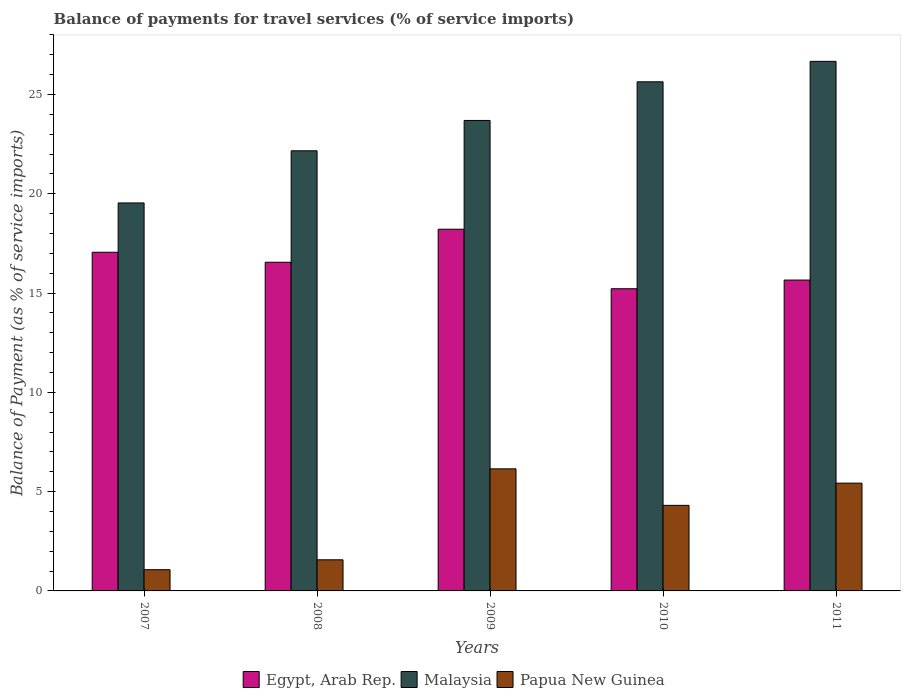How many groups of bars are there?
Offer a very short reply. 5. Are the number of bars on each tick of the X-axis equal?
Your answer should be compact. Yes. In how many cases, is the number of bars for a given year not equal to the number of legend labels?
Your response must be concise. 0. What is the balance of payments for travel services in Papua New Guinea in 2007?
Offer a terse response. 1.07. Across all years, what is the maximum balance of payments for travel services in Malaysia?
Keep it short and to the point. 26.67. Across all years, what is the minimum balance of payments for travel services in Papua New Guinea?
Offer a very short reply. 1.07. What is the total balance of payments for travel services in Egypt, Arab Rep. in the graph?
Ensure brevity in your answer.  82.69. What is the difference between the balance of payments for travel services in Egypt, Arab Rep. in 2007 and that in 2010?
Make the answer very short. 1.84. What is the difference between the balance of payments for travel services in Malaysia in 2010 and the balance of payments for travel services in Egypt, Arab Rep. in 2009?
Offer a very short reply. 7.42. What is the average balance of payments for travel services in Egypt, Arab Rep. per year?
Provide a short and direct response. 16.54. In the year 2011, what is the difference between the balance of payments for travel services in Malaysia and balance of payments for travel services in Egypt, Arab Rep.?
Your response must be concise. 11.01. In how many years, is the balance of payments for travel services in Papua New Guinea greater than 4 %?
Offer a terse response. 3. What is the ratio of the balance of payments for travel services in Papua New Guinea in 2008 to that in 2010?
Keep it short and to the point. 0.36. What is the difference between the highest and the second highest balance of payments for travel services in Malaysia?
Your response must be concise. 1.03. What is the difference between the highest and the lowest balance of payments for travel services in Papua New Guinea?
Give a very brief answer. 5.08. In how many years, is the balance of payments for travel services in Egypt, Arab Rep. greater than the average balance of payments for travel services in Egypt, Arab Rep. taken over all years?
Provide a short and direct response. 3. What does the 3rd bar from the left in 2011 represents?
Your answer should be compact. Papua New Guinea. What does the 3rd bar from the right in 2007 represents?
Ensure brevity in your answer.  Egypt, Arab Rep. Are all the bars in the graph horizontal?
Your answer should be very brief. No. How many years are there in the graph?
Provide a short and direct response. 5. Are the values on the major ticks of Y-axis written in scientific E-notation?
Provide a succinct answer. No. Where does the legend appear in the graph?
Give a very brief answer. Bottom center. How many legend labels are there?
Offer a very short reply. 3. How are the legend labels stacked?
Offer a very short reply. Horizontal. What is the title of the graph?
Your answer should be very brief. Balance of payments for travel services (% of service imports). Does "Brazil" appear as one of the legend labels in the graph?
Provide a succinct answer. No. What is the label or title of the Y-axis?
Give a very brief answer. Balance of Payment (as % of service imports). What is the Balance of Payment (as % of service imports) of Egypt, Arab Rep. in 2007?
Offer a terse response. 17.05. What is the Balance of Payment (as % of service imports) in Malaysia in 2007?
Provide a succinct answer. 19.54. What is the Balance of Payment (as % of service imports) of Papua New Guinea in 2007?
Provide a succinct answer. 1.07. What is the Balance of Payment (as % of service imports) in Egypt, Arab Rep. in 2008?
Keep it short and to the point. 16.55. What is the Balance of Payment (as % of service imports) of Malaysia in 2008?
Give a very brief answer. 22.16. What is the Balance of Payment (as % of service imports) in Papua New Guinea in 2008?
Keep it short and to the point. 1.57. What is the Balance of Payment (as % of service imports) in Egypt, Arab Rep. in 2009?
Keep it short and to the point. 18.21. What is the Balance of Payment (as % of service imports) in Malaysia in 2009?
Provide a short and direct response. 23.69. What is the Balance of Payment (as % of service imports) of Papua New Guinea in 2009?
Provide a succinct answer. 6.15. What is the Balance of Payment (as % of service imports) of Egypt, Arab Rep. in 2010?
Your response must be concise. 15.22. What is the Balance of Payment (as % of service imports) in Malaysia in 2010?
Provide a short and direct response. 25.64. What is the Balance of Payment (as % of service imports) in Papua New Guinea in 2010?
Your answer should be compact. 4.31. What is the Balance of Payment (as % of service imports) in Egypt, Arab Rep. in 2011?
Give a very brief answer. 15.65. What is the Balance of Payment (as % of service imports) of Malaysia in 2011?
Offer a terse response. 26.67. What is the Balance of Payment (as % of service imports) in Papua New Guinea in 2011?
Provide a short and direct response. 5.43. Across all years, what is the maximum Balance of Payment (as % of service imports) in Egypt, Arab Rep.?
Your answer should be compact. 18.21. Across all years, what is the maximum Balance of Payment (as % of service imports) of Malaysia?
Make the answer very short. 26.67. Across all years, what is the maximum Balance of Payment (as % of service imports) in Papua New Guinea?
Give a very brief answer. 6.15. Across all years, what is the minimum Balance of Payment (as % of service imports) of Egypt, Arab Rep.?
Your response must be concise. 15.22. Across all years, what is the minimum Balance of Payment (as % of service imports) in Malaysia?
Provide a short and direct response. 19.54. Across all years, what is the minimum Balance of Payment (as % of service imports) in Papua New Guinea?
Give a very brief answer. 1.07. What is the total Balance of Payment (as % of service imports) in Egypt, Arab Rep. in the graph?
Offer a very short reply. 82.69. What is the total Balance of Payment (as % of service imports) in Malaysia in the graph?
Offer a very short reply. 117.7. What is the total Balance of Payment (as % of service imports) of Papua New Guinea in the graph?
Keep it short and to the point. 18.52. What is the difference between the Balance of Payment (as % of service imports) in Egypt, Arab Rep. in 2007 and that in 2008?
Offer a very short reply. 0.5. What is the difference between the Balance of Payment (as % of service imports) in Malaysia in 2007 and that in 2008?
Provide a short and direct response. -2.63. What is the difference between the Balance of Payment (as % of service imports) in Papua New Guinea in 2007 and that in 2008?
Provide a short and direct response. -0.5. What is the difference between the Balance of Payment (as % of service imports) of Egypt, Arab Rep. in 2007 and that in 2009?
Provide a succinct answer. -1.16. What is the difference between the Balance of Payment (as % of service imports) in Malaysia in 2007 and that in 2009?
Your response must be concise. -4.15. What is the difference between the Balance of Payment (as % of service imports) in Papua New Guinea in 2007 and that in 2009?
Give a very brief answer. -5.08. What is the difference between the Balance of Payment (as % of service imports) of Egypt, Arab Rep. in 2007 and that in 2010?
Ensure brevity in your answer.  1.84. What is the difference between the Balance of Payment (as % of service imports) of Malaysia in 2007 and that in 2010?
Offer a very short reply. -6.1. What is the difference between the Balance of Payment (as % of service imports) of Papua New Guinea in 2007 and that in 2010?
Your response must be concise. -3.24. What is the difference between the Balance of Payment (as % of service imports) of Egypt, Arab Rep. in 2007 and that in 2011?
Offer a terse response. 1.4. What is the difference between the Balance of Payment (as % of service imports) in Malaysia in 2007 and that in 2011?
Offer a terse response. -7.13. What is the difference between the Balance of Payment (as % of service imports) of Papua New Guinea in 2007 and that in 2011?
Give a very brief answer. -4.36. What is the difference between the Balance of Payment (as % of service imports) in Egypt, Arab Rep. in 2008 and that in 2009?
Keep it short and to the point. -1.66. What is the difference between the Balance of Payment (as % of service imports) of Malaysia in 2008 and that in 2009?
Provide a succinct answer. -1.53. What is the difference between the Balance of Payment (as % of service imports) of Papua New Guinea in 2008 and that in 2009?
Offer a very short reply. -4.58. What is the difference between the Balance of Payment (as % of service imports) of Egypt, Arab Rep. in 2008 and that in 2010?
Offer a very short reply. 1.33. What is the difference between the Balance of Payment (as % of service imports) in Malaysia in 2008 and that in 2010?
Provide a succinct answer. -3.47. What is the difference between the Balance of Payment (as % of service imports) of Papua New Guinea in 2008 and that in 2010?
Your answer should be very brief. -2.74. What is the difference between the Balance of Payment (as % of service imports) of Egypt, Arab Rep. in 2008 and that in 2011?
Ensure brevity in your answer.  0.9. What is the difference between the Balance of Payment (as % of service imports) of Malaysia in 2008 and that in 2011?
Provide a succinct answer. -4.5. What is the difference between the Balance of Payment (as % of service imports) in Papua New Guinea in 2008 and that in 2011?
Provide a short and direct response. -3.86. What is the difference between the Balance of Payment (as % of service imports) in Egypt, Arab Rep. in 2009 and that in 2010?
Provide a short and direct response. 3. What is the difference between the Balance of Payment (as % of service imports) in Malaysia in 2009 and that in 2010?
Make the answer very short. -1.95. What is the difference between the Balance of Payment (as % of service imports) in Papua New Guinea in 2009 and that in 2010?
Your response must be concise. 1.84. What is the difference between the Balance of Payment (as % of service imports) of Egypt, Arab Rep. in 2009 and that in 2011?
Your response must be concise. 2.56. What is the difference between the Balance of Payment (as % of service imports) of Malaysia in 2009 and that in 2011?
Provide a short and direct response. -2.98. What is the difference between the Balance of Payment (as % of service imports) in Papua New Guinea in 2009 and that in 2011?
Make the answer very short. 0.72. What is the difference between the Balance of Payment (as % of service imports) of Egypt, Arab Rep. in 2010 and that in 2011?
Make the answer very short. -0.44. What is the difference between the Balance of Payment (as % of service imports) of Malaysia in 2010 and that in 2011?
Provide a short and direct response. -1.03. What is the difference between the Balance of Payment (as % of service imports) in Papua New Guinea in 2010 and that in 2011?
Give a very brief answer. -1.12. What is the difference between the Balance of Payment (as % of service imports) of Egypt, Arab Rep. in 2007 and the Balance of Payment (as % of service imports) of Malaysia in 2008?
Provide a succinct answer. -5.11. What is the difference between the Balance of Payment (as % of service imports) of Egypt, Arab Rep. in 2007 and the Balance of Payment (as % of service imports) of Papua New Guinea in 2008?
Your answer should be very brief. 15.49. What is the difference between the Balance of Payment (as % of service imports) of Malaysia in 2007 and the Balance of Payment (as % of service imports) of Papua New Guinea in 2008?
Your answer should be very brief. 17.97. What is the difference between the Balance of Payment (as % of service imports) of Egypt, Arab Rep. in 2007 and the Balance of Payment (as % of service imports) of Malaysia in 2009?
Your answer should be very brief. -6.64. What is the difference between the Balance of Payment (as % of service imports) of Egypt, Arab Rep. in 2007 and the Balance of Payment (as % of service imports) of Papua New Guinea in 2009?
Your answer should be compact. 10.91. What is the difference between the Balance of Payment (as % of service imports) in Malaysia in 2007 and the Balance of Payment (as % of service imports) in Papua New Guinea in 2009?
Your answer should be compact. 13.39. What is the difference between the Balance of Payment (as % of service imports) in Egypt, Arab Rep. in 2007 and the Balance of Payment (as % of service imports) in Malaysia in 2010?
Keep it short and to the point. -8.58. What is the difference between the Balance of Payment (as % of service imports) in Egypt, Arab Rep. in 2007 and the Balance of Payment (as % of service imports) in Papua New Guinea in 2010?
Your answer should be very brief. 12.74. What is the difference between the Balance of Payment (as % of service imports) in Malaysia in 2007 and the Balance of Payment (as % of service imports) in Papua New Guinea in 2010?
Give a very brief answer. 15.23. What is the difference between the Balance of Payment (as % of service imports) in Egypt, Arab Rep. in 2007 and the Balance of Payment (as % of service imports) in Malaysia in 2011?
Offer a terse response. -9.61. What is the difference between the Balance of Payment (as % of service imports) in Egypt, Arab Rep. in 2007 and the Balance of Payment (as % of service imports) in Papua New Guinea in 2011?
Give a very brief answer. 11.63. What is the difference between the Balance of Payment (as % of service imports) of Malaysia in 2007 and the Balance of Payment (as % of service imports) of Papua New Guinea in 2011?
Keep it short and to the point. 14.11. What is the difference between the Balance of Payment (as % of service imports) of Egypt, Arab Rep. in 2008 and the Balance of Payment (as % of service imports) of Malaysia in 2009?
Your answer should be compact. -7.14. What is the difference between the Balance of Payment (as % of service imports) in Egypt, Arab Rep. in 2008 and the Balance of Payment (as % of service imports) in Papua New Guinea in 2009?
Your response must be concise. 10.4. What is the difference between the Balance of Payment (as % of service imports) in Malaysia in 2008 and the Balance of Payment (as % of service imports) in Papua New Guinea in 2009?
Your response must be concise. 16.02. What is the difference between the Balance of Payment (as % of service imports) in Egypt, Arab Rep. in 2008 and the Balance of Payment (as % of service imports) in Malaysia in 2010?
Provide a succinct answer. -9.09. What is the difference between the Balance of Payment (as % of service imports) in Egypt, Arab Rep. in 2008 and the Balance of Payment (as % of service imports) in Papua New Guinea in 2010?
Give a very brief answer. 12.24. What is the difference between the Balance of Payment (as % of service imports) in Malaysia in 2008 and the Balance of Payment (as % of service imports) in Papua New Guinea in 2010?
Make the answer very short. 17.85. What is the difference between the Balance of Payment (as % of service imports) of Egypt, Arab Rep. in 2008 and the Balance of Payment (as % of service imports) of Malaysia in 2011?
Provide a short and direct response. -10.12. What is the difference between the Balance of Payment (as % of service imports) in Egypt, Arab Rep. in 2008 and the Balance of Payment (as % of service imports) in Papua New Guinea in 2011?
Your response must be concise. 11.12. What is the difference between the Balance of Payment (as % of service imports) of Malaysia in 2008 and the Balance of Payment (as % of service imports) of Papua New Guinea in 2011?
Your response must be concise. 16.74. What is the difference between the Balance of Payment (as % of service imports) in Egypt, Arab Rep. in 2009 and the Balance of Payment (as % of service imports) in Malaysia in 2010?
Make the answer very short. -7.42. What is the difference between the Balance of Payment (as % of service imports) in Egypt, Arab Rep. in 2009 and the Balance of Payment (as % of service imports) in Papua New Guinea in 2010?
Your answer should be compact. 13.9. What is the difference between the Balance of Payment (as % of service imports) in Malaysia in 2009 and the Balance of Payment (as % of service imports) in Papua New Guinea in 2010?
Provide a short and direct response. 19.38. What is the difference between the Balance of Payment (as % of service imports) in Egypt, Arab Rep. in 2009 and the Balance of Payment (as % of service imports) in Malaysia in 2011?
Your response must be concise. -8.45. What is the difference between the Balance of Payment (as % of service imports) of Egypt, Arab Rep. in 2009 and the Balance of Payment (as % of service imports) of Papua New Guinea in 2011?
Offer a terse response. 12.79. What is the difference between the Balance of Payment (as % of service imports) of Malaysia in 2009 and the Balance of Payment (as % of service imports) of Papua New Guinea in 2011?
Your response must be concise. 18.26. What is the difference between the Balance of Payment (as % of service imports) of Egypt, Arab Rep. in 2010 and the Balance of Payment (as % of service imports) of Malaysia in 2011?
Provide a short and direct response. -11.45. What is the difference between the Balance of Payment (as % of service imports) of Egypt, Arab Rep. in 2010 and the Balance of Payment (as % of service imports) of Papua New Guinea in 2011?
Provide a succinct answer. 9.79. What is the difference between the Balance of Payment (as % of service imports) of Malaysia in 2010 and the Balance of Payment (as % of service imports) of Papua New Guinea in 2011?
Offer a terse response. 20.21. What is the average Balance of Payment (as % of service imports) in Egypt, Arab Rep. per year?
Provide a succinct answer. 16.54. What is the average Balance of Payment (as % of service imports) in Malaysia per year?
Make the answer very short. 23.54. What is the average Balance of Payment (as % of service imports) of Papua New Guinea per year?
Provide a succinct answer. 3.7. In the year 2007, what is the difference between the Balance of Payment (as % of service imports) in Egypt, Arab Rep. and Balance of Payment (as % of service imports) in Malaysia?
Your response must be concise. -2.48. In the year 2007, what is the difference between the Balance of Payment (as % of service imports) in Egypt, Arab Rep. and Balance of Payment (as % of service imports) in Papua New Guinea?
Ensure brevity in your answer.  15.98. In the year 2007, what is the difference between the Balance of Payment (as % of service imports) in Malaysia and Balance of Payment (as % of service imports) in Papua New Guinea?
Provide a short and direct response. 18.47. In the year 2008, what is the difference between the Balance of Payment (as % of service imports) in Egypt, Arab Rep. and Balance of Payment (as % of service imports) in Malaysia?
Offer a very short reply. -5.61. In the year 2008, what is the difference between the Balance of Payment (as % of service imports) of Egypt, Arab Rep. and Balance of Payment (as % of service imports) of Papua New Guinea?
Your answer should be very brief. 14.98. In the year 2008, what is the difference between the Balance of Payment (as % of service imports) in Malaysia and Balance of Payment (as % of service imports) in Papua New Guinea?
Make the answer very short. 20.6. In the year 2009, what is the difference between the Balance of Payment (as % of service imports) of Egypt, Arab Rep. and Balance of Payment (as % of service imports) of Malaysia?
Your response must be concise. -5.48. In the year 2009, what is the difference between the Balance of Payment (as % of service imports) in Egypt, Arab Rep. and Balance of Payment (as % of service imports) in Papua New Guinea?
Ensure brevity in your answer.  12.07. In the year 2009, what is the difference between the Balance of Payment (as % of service imports) of Malaysia and Balance of Payment (as % of service imports) of Papua New Guinea?
Provide a short and direct response. 17.54. In the year 2010, what is the difference between the Balance of Payment (as % of service imports) of Egypt, Arab Rep. and Balance of Payment (as % of service imports) of Malaysia?
Make the answer very short. -10.42. In the year 2010, what is the difference between the Balance of Payment (as % of service imports) in Egypt, Arab Rep. and Balance of Payment (as % of service imports) in Papua New Guinea?
Provide a short and direct response. 10.91. In the year 2010, what is the difference between the Balance of Payment (as % of service imports) in Malaysia and Balance of Payment (as % of service imports) in Papua New Guinea?
Keep it short and to the point. 21.33. In the year 2011, what is the difference between the Balance of Payment (as % of service imports) in Egypt, Arab Rep. and Balance of Payment (as % of service imports) in Malaysia?
Your response must be concise. -11.01. In the year 2011, what is the difference between the Balance of Payment (as % of service imports) in Egypt, Arab Rep. and Balance of Payment (as % of service imports) in Papua New Guinea?
Give a very brief answer. 10.23. In the year 2011, what is the difference between the Balance of Payment (as % of service imports) of Malaysia and Balance of Payment (as % of service imports) of Papua New Guinea?
Offer a terse response. 21.24. What is the ratio of the Balance of Payment (as % of service imports) of Egypt, Arab Rep. in 2007 to that in 2008?
Your response must be concise. 1.03. What is the ratio of the Balance of Payment (as % of service imports) of Malaysia in 2007 to that in 2008?
Give a very brief answer. 0.88. What is the ratio of the Balance of Payment (as % of service imports) of Papua New Guinea in 2007 to that in 2008?
Provide a succinct answer. 0.68. What is the ratio of the Balance of Payment (as % of service imports) of Egypt, Arab Rep. in 2007 to that in 2009?
Ensure brevity in your answer.  0.94. What is the ratio of the Balance of Payment (as % of service imports) of Malaysia in 2007 to that in 2009?
Your answer should be compact. 0.82. What is the ratio of the Balance of Payment (as % of service imports) of Papua New Guinea in 2007 to that in 2009?
Ensure brevity in your answer.  0.17. What is the ratio of the Balance of Payment (as % of service imports) in Egypt, Arab Rep. in 2007 to that in 2010?
Provide a succinct answer. 1.12. What is the ratio of the Balance of Payment (as % of service imports) of Malaysia in 2007 to that in 2010?
Make the answer very short. 0.76. What is the ratio of the Balance of Payment (as % of service imports) of Papua New Guinea in 2007 to that in 2010?
Your response must be concise. 0.25. What is the ratio of the Balance of Payment (as % of service imports) of Egypt, Arab Rep. in 2007 to that in 2011?
Offer a terse response. 1.09. What is the ratio of the Balance of Payment (as % of service imports) in Malaysia in 2007 to that in 2011?
Keep it short and to the point. 0.73. What is the ratio of the Balance of Payment (as % of service imports) of Papua New Guinea in 2007 to that in 2011?
Your response must be concise. 0.2. What is the ratio of the Balance of Payment (as % of service imports) of Egypt, Arab Rep. in 2008 to that in 2009?
Make the answer very short. 0.91. What is the ratio of the Balance of Payment (as % of service imports) in Malaysia in 2008 to that in 2009?
Provide a succinct answer. 0.94. What is the ratio of the Balance of Payment (as % of service imports) of Papua New Guinea in 2008 to that in 2009?
Your answer should be compact. 0.25. What is the ratio of the Balance of Payment (as % of service imports) of Egypt, Arab Rep. in 2008 to that in 2010?
Offer a terse response. 1.09. What is the ratio of the Balance of Payment (as % of service imports) in Malaysia in 2008 to that in 2010?
Your answer should be compact. 0.86. What is the ratio of the Balance of Payment (as % of service imports) of Papua New Guinea in 2008 to that in 2010?
Your answer should be very brief. 0.36. What is the ratio of the Balance of Payment (as % of service imports) of Egypt, Arab Rep. in 2008 to that in 2011?
Your response must be concise. 1.06. What is the ratio of the Balance of Payment (as % of service imports) in Malaysia in 2008 to that in 2011?
Keep it short and to the point. 0.83. What is the ratio of the Balance of Payment (as % of service imports) in Papua New Guinea in 2008 to that in 2011?
Offer a terse response. 0.29. What is the ratio of the Balance of Payment (as % of service imports) of Egypt, Arab Rep. in 2009 to that in 2010?
Your answer should be very brief. 1.2. What is the ratio of the Balance of Payment (as % of service imports) of Malaysia in 2009 to that in 2010?
Make the answer very short. 0.92. What is the ratio of the Balance of Payment (as % of service imports) in Papua New Guinea in 2009 to that in 2010?
Your answer should be very brief. 1.43. What is the ratio of the Balance of Payment (as % of service imports) in Egypt, Arab Rep. in 2009 to that in 2011?
Offer a very short reply. 1.16. What is the ratio of the Balance of Payment (as % of service imports) of Malaysia in 2009 to that in 2011?
Provide a short and direct response. 0.89. What is the ratio of the Balance of Payment (as % of service imports) in Papua New Guinea in 2009 to that in 2011?
Offer a terse response. 1.13. What is the ratio of the Balance of Payment (as % of service imports) in Egypt, Arab Rep. in 2010 to that in 2011?
Offer a very short reply. 0.97. What is the ratio of the Balance of Payment (as % of service imports) in Malaysia in 2010 to that in 2011?
Give a very brief answer. 0.96. What is the ratio of the Balance of Payment (as % of service imports) in Papua New Guinea in 2010 to that in 2011?
Your answer should be compact. 0.79. What is the difference between the highest and the second highest Balance of Payment (as % of service imports) in Egypt, Arab Rep.?
Make the answer very short. 1.16. What is the difference between the highest and the second highest Balance of Payment (as % of service imports) in Malaysia?
Provide a succinct answer. 1.03. What is the difference between the highest and the second highest Balance of Payment (as % of service imports) of Papua New Guinea?
Offer a very short reply. 0.72. What is the difference between the highest and the lowest Balance of Payment (as % of service imports) of Egypt, Arab Rep.?
Your response must be concise. 3. What is the difference between the highest and the lowest Balance of Payment (as % of service imports) of Malaysia?
Provide a short and direct response. 7.13. What is the difference between the highest and the lowest Balance of Payment (as % of service imports) of Papua New Guinea?
Provide a succinct answer. 5.08. 